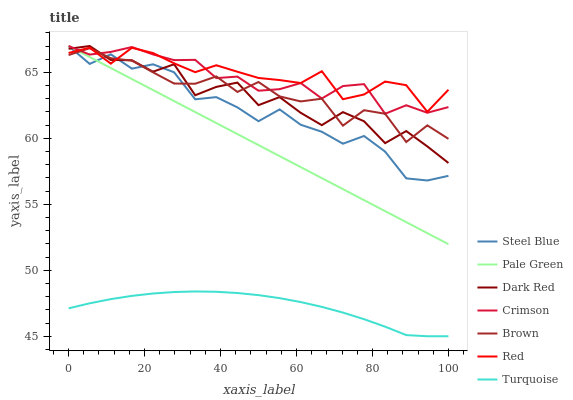Does Turquoise have the minimum area under the curve?
Answer yes or no. Yes. Does Red have the maximum area under the curve?
Answer yes or no. Yes. Does Dark Red have the minimum area under the curve?
Answer yes or no. No. Does Dark Red have the maximum area under the curve?
Answer yes or no. No. Is Pale Green the smoothest?
Answer yes or no. Yes. Is Dark Red the roughest?
Answer yes or no. Yes. Is Turquoise the smoothest?
Answer yes or no. No. Is Turquoise the roughest?
Answer yes or no. No. Does Turquoise have the lowest value?
Answer yes or no. Yes. Does Dark Red have the lowest value?
Answer yes or no. No. Does Crimson have the highest value?
Answer yes or no. Yes. Does Turquoise have the highest value?
Answer yes or no. No. Is Turquoise less than Pale Green?
Answer yes or no. Yes. Is Crimson greater than Turquoise?
Answer yes or no. Yes. Does Dark Red intersect Pale Green?
Answer yes or no. Yes. Is Dark Red less than Pale Green?
Answer yes or no. No. Is Dark Red greater than Pale Green?
Answer yes or no. No. Does Turquoise intersect Pale Green?
Answer yes or no. No. 